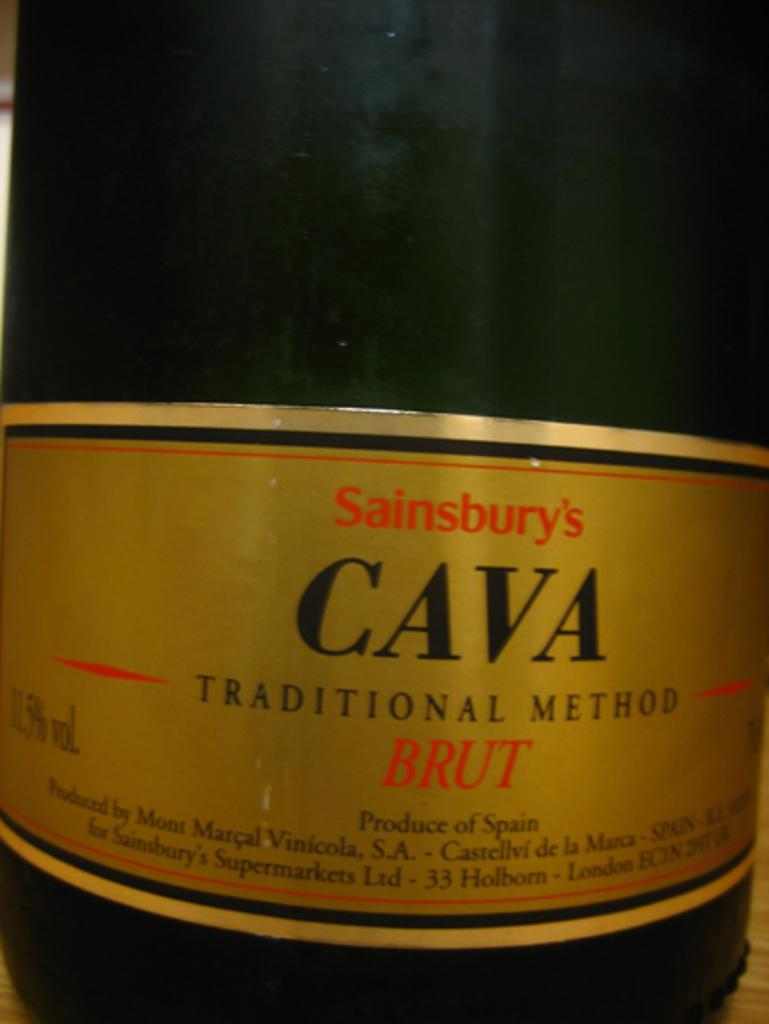<image>
Relay a brief, clear account of the picture shown. A label of Sainsbury's Cava traditional method bru 